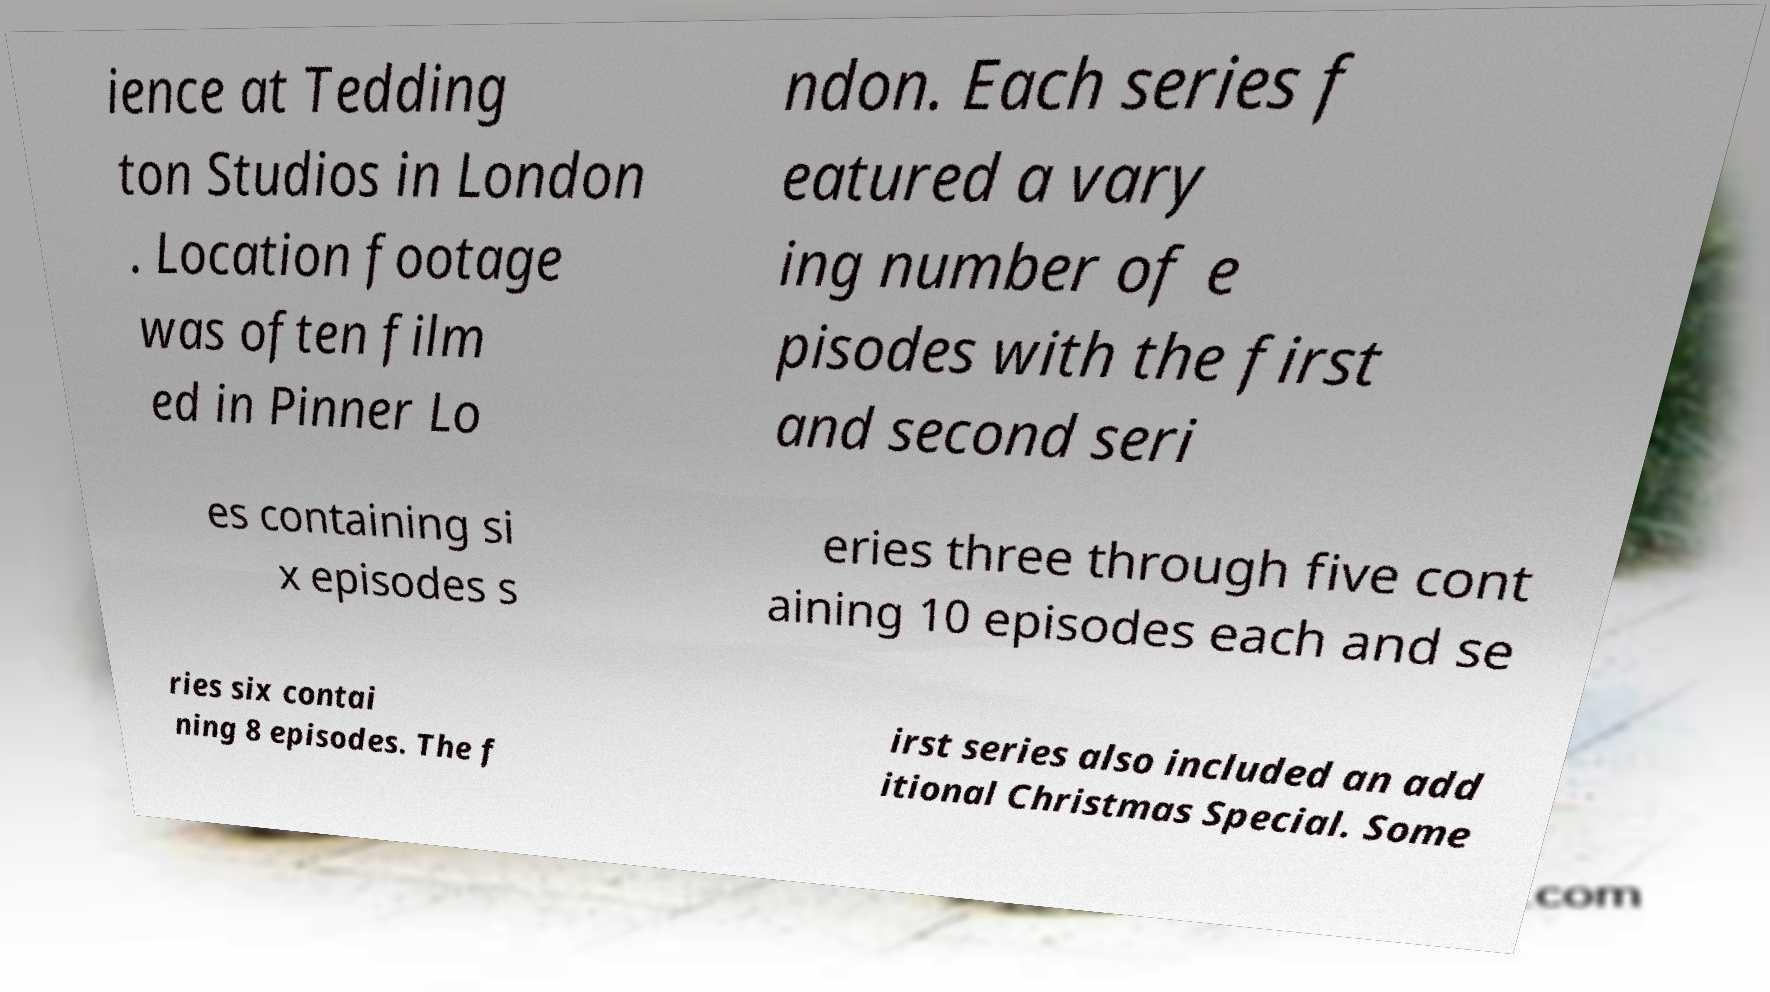Could you assist in decoding the text presented in this image and type it out clearly? ience at Tedding ton Studios in London . Location footage was often film ed in Pinner Lo ndon. Each series f eatured a vary ing number of e pisodes with the first and second seri es containing si x episodes s eries three through five cont aining 10 episodes each and se ries six contai ning 8 episodes. The f irst series also included an add itional Christmas Special. Some 